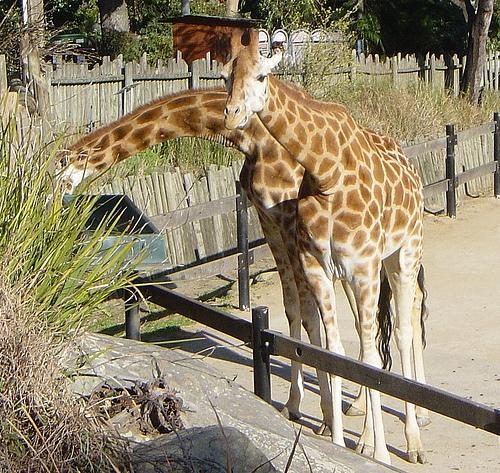Does this giraffe have 2 heads?
Write a very short answer. No. Is the giraffe eating?
Short answer required. Yes. What kind of fence is this?
Be succinct. Wooden. 